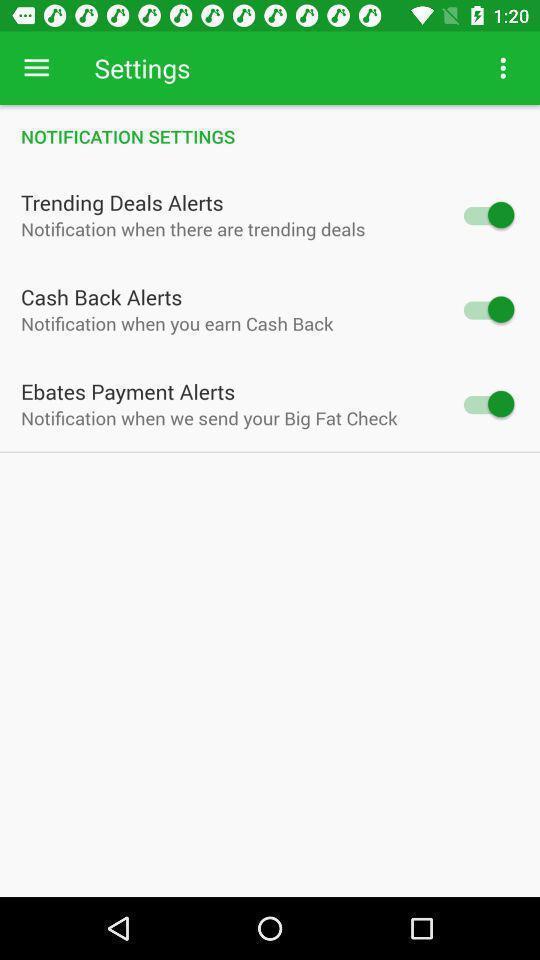Provide a textual representation of this image. Screen shows settings of shopping app. 